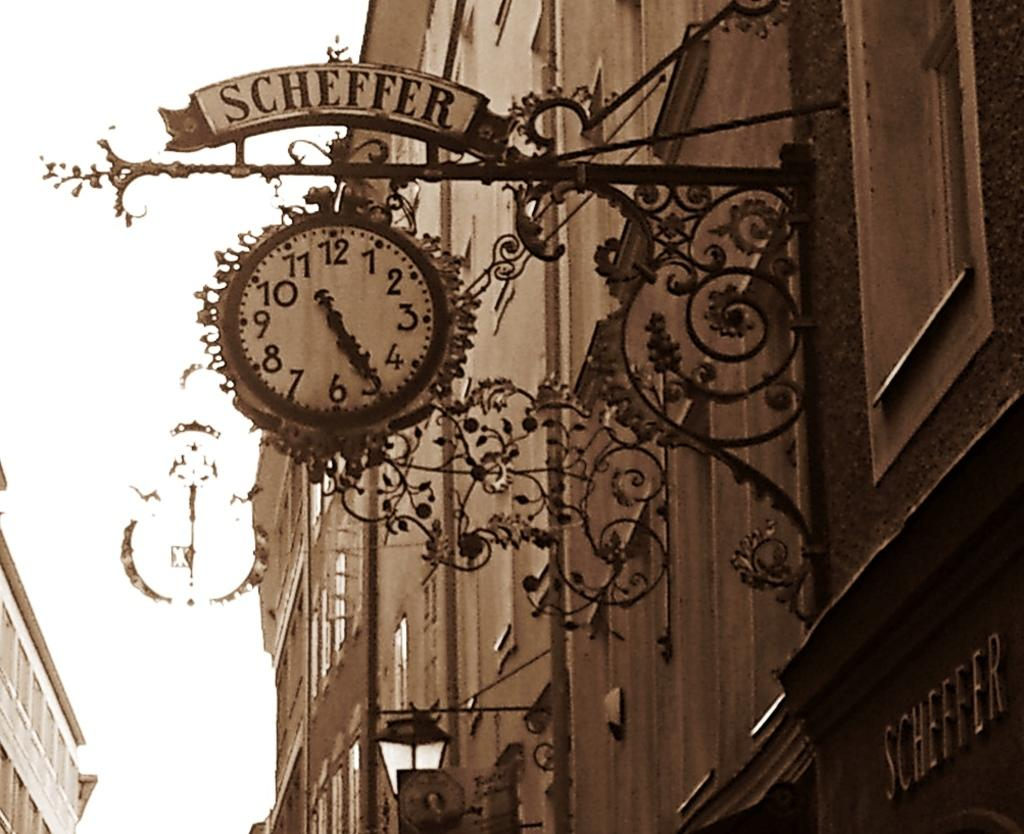<image>
Describe the image concisely. a clock with the word scheffer at the top 